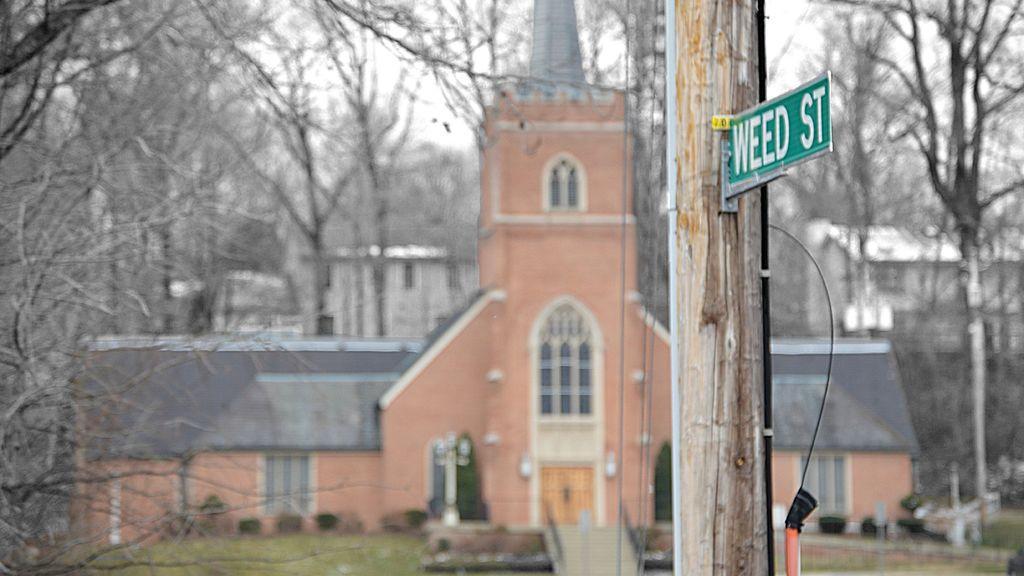Describe this image in one or two sentences. In this picture we can see there is a pole with a board and cables. Behind the pole there are trees, buildings and the sky. 